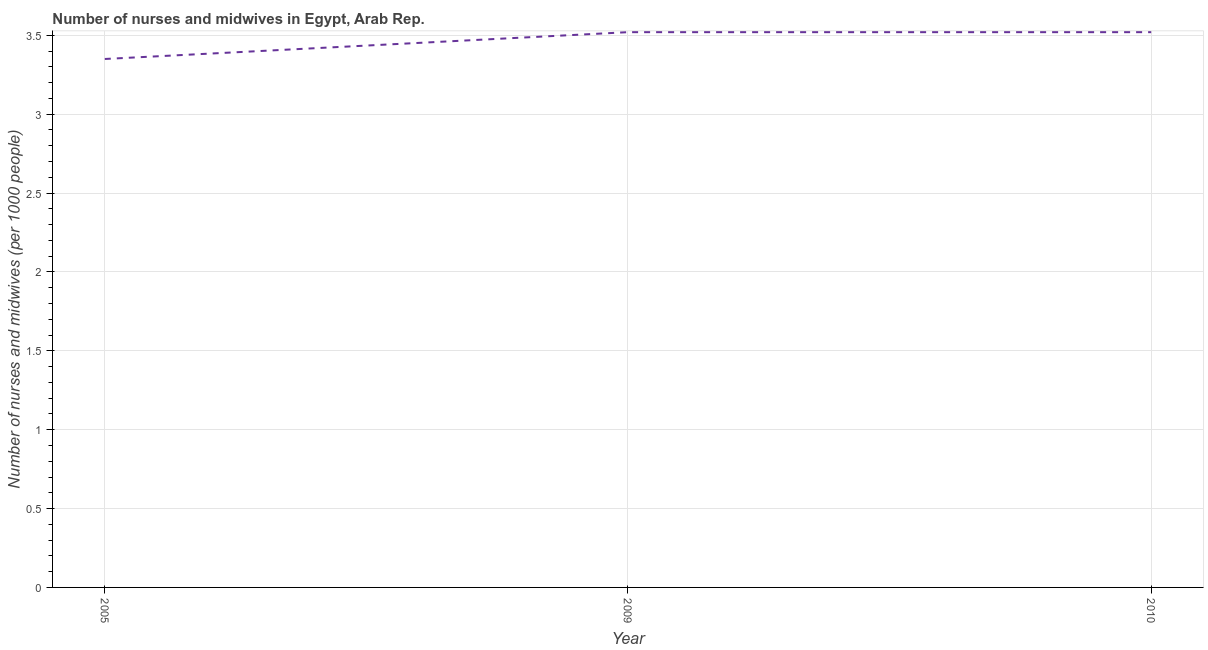What is the number of nurses and midwives in 2010?
Offer a very short reply. 3.52. Across all years, what is the maximum number of nurses and midwives?
Provide a succinct answer. 3.52. Across all years, what is the minimum number of nurses and midwives?
Provide a succinct answer. 3.35. In which year was the number of nurses and midwives maximum?
Your answer should be very brief. 2009. In which year was the number of nurses and midwives minimum?
Provide a succinct answer. 2005. What is the sum of the number of nurses and midwives?
Provide a succinct answer. 10.39. What is the difference between the number of nurses and midwives in 2005 and 2009?
Offer a very short reply. -0.17. What is the average number of nurses and midwives per year?
Offer a terse response. 3.46. What is the median number of nurses and midwives?
Your answer should be very brief. 3.52. What is the ratio of the number of nurses and midwives in 2005 to that in 2010?
Ensure brevity in your answer.  0.95. Is the number of nurses and midwives in 2005 less than that in 2009?
Make the answer very short. Yes. Is the difference between the number of nurses and midwives in 2009 and 2010 greater than the difference between any two years?
Offer a very short reply. No. Is the sum of the number of nurses and midwives in 2005 and 2010 greater than the maximum number of nurses and midwives across all years?
Keep it short and to the point. Yes. What is the difference between the highest and the lowest number of nurses and midwives?
Your response must be concise. 0.17. What is the difference between two consecutive major ticks on the Y-axis?
Your answer should be compact. 0.5. Does the graph contain any zero values?
Make the answer very short. No. Does the graph contain grids?
Your answer should be compact. Yes. What is the title of the graph?
Provide a short and direct response. Number of nurses and midwives in Egypt, Arab Rep. What is the label or title of the X-axis?
Offer a terse response. Year. What is the label or title of the Y-axis?
Offer a terse response. Number of nurses and midwives (per 1000 people). What is the Number of nurses and midwives (per 1000 people) in 2005?
Your response must be concise. 3.35. What is the Number of nurses and midwives (per 1000 people) of 2009?
Provide a succinct answer. 3.52. What is the Number of nurses and midwives (per 1000 people) in 2010?
Your response must be concise. 3.52. What is the difference between the Number of nurses and midwives (per 1000 people) in 2005 and 2009?
Make the answer very short. -0.17. What is the difference between the Number of nurses and midwives (per 1000 people) in 2005 and 2010?
Offer a terse response. -0.17. What is the difference between the Number of nurses and midwives (per 1000 people) in 2009 and 2010?
Keep it short and to the point. 0. What is the ratio of the Number of nurses and midwives (per 1000 people) in 2005 to that in 2009?
Your answer should be compact. 0.95. 